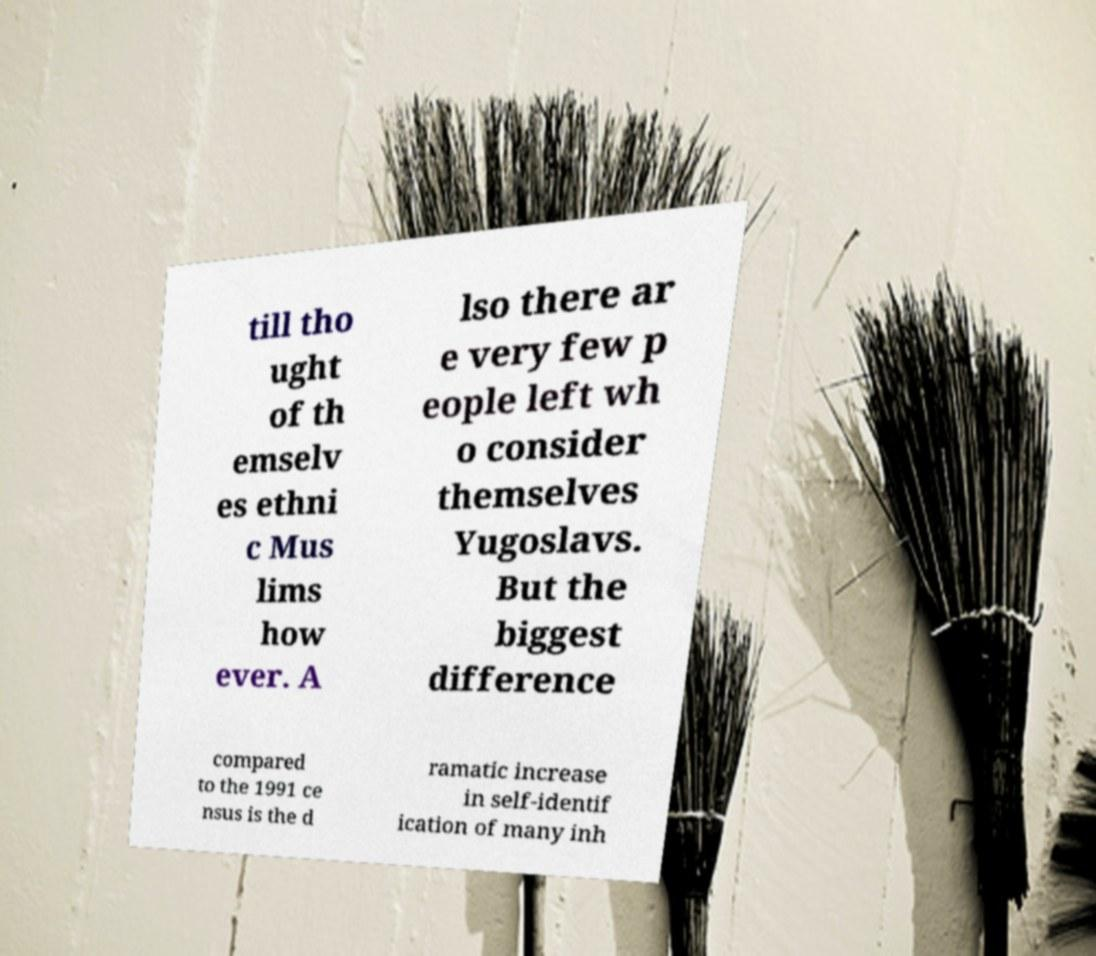There's text embedded in this image that I need extracted. Can you transcribe it verbatim? till tho ught of th emselv es ethni c Mus lims how ever. A lso there ar e very few p eople left wh o consider themselves Yugoslavs. But the biggest difference compared to the 1991 ce nsus is the d ramatic increase in self-identif ication of many inh 